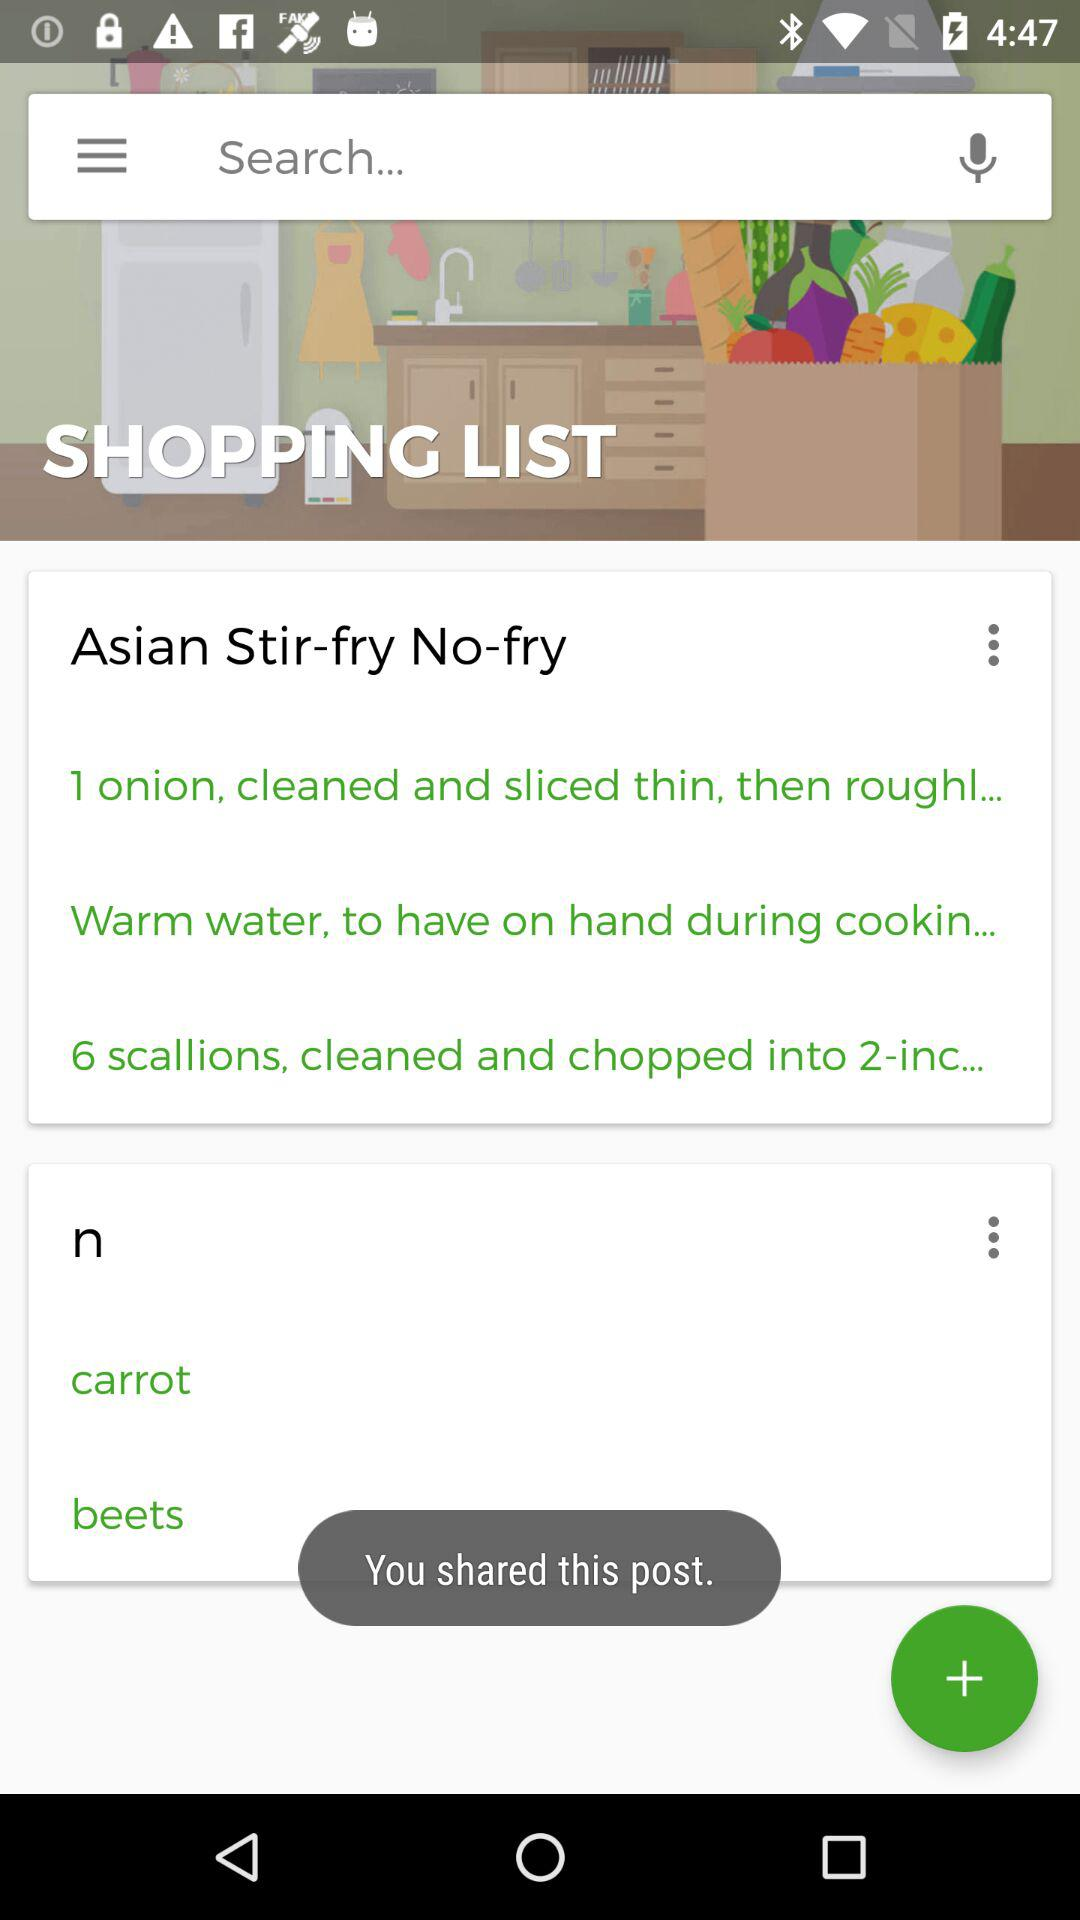How many ingredients have three dots next to them?
Answer the question using a single word or phrase. 2 